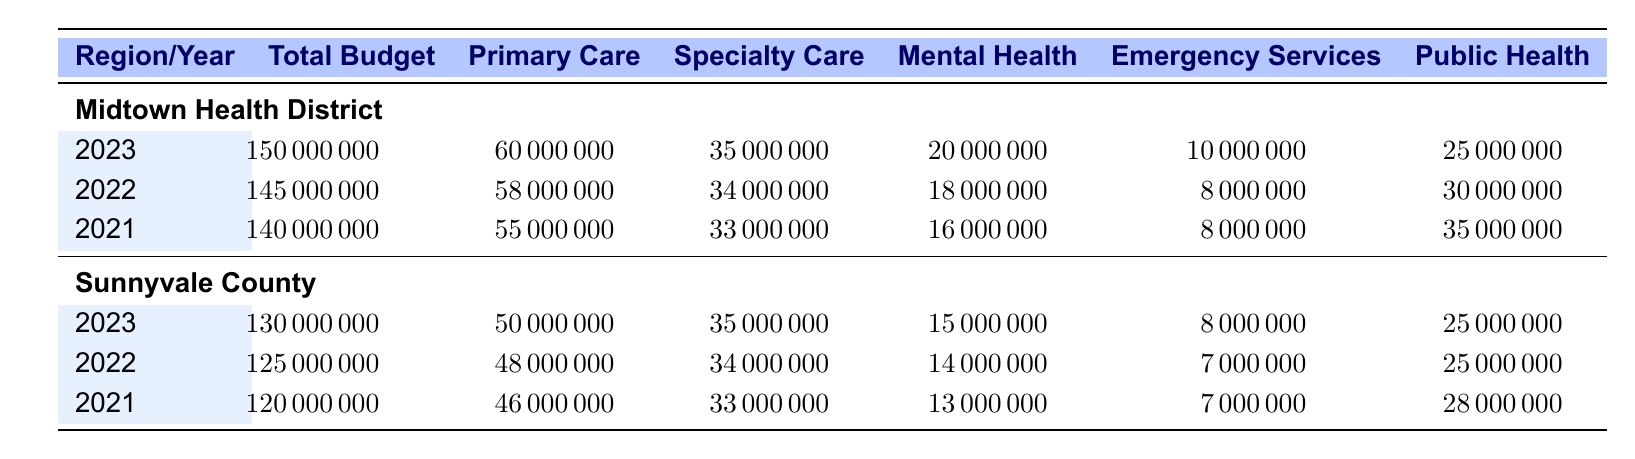What was the total healthcare budget for Midtown Health District in 2023? The table explicitly shows the total budget for Midtown Health District in 2023 as 150,000,000.
Answer: 150000000 How much was allocated to Mental Health in Sunnyvale County for the year 2022? Looking at the Sunnyvale County row for the year 2022, the allocation for Mental Health is clearly listed as 14,000,000.
Answer: 14000000 What is the difference in total budget between Midtown Health District in 2023 and 2022? To find the difference, I subtract the 2022 total budget (145,000,000) from the 2023 total budget (150,000,000), resulting in a difference of 5,000,000.
Answer: 5000000 Did Midtown Health District have a higher budget for Emergency Services in 2023 than Sunnyvale County in the same year? The Emergency Services budget for Midtown Health District in 2023 is 10,000,000 and for Sunnyvale County in 2023, it is 8,000,000. Since 10,000,000 is greater than 8,000,000, the answer is yes.
Answer: Yes What is the average allocation for Specialty Care across both regions for the year 2021? First, I find the Specialty Care allocation for both regions in 2021: Midtown Health District is 33,000,000 and Sunnyvale County is 33,000,000. Adding these gives 66,000,000. There are 2 data points, so the average is 66,000,000 divided by 2 = 33,000,000.
Answer: 33000000 In which year did Midtown Health District allocate the most to Public Health Initiatives? Looking at the Public Health Initiatives for Midtown Health District, in 2021 it was 35,000,000, in 2022 it was 30,000,000, and in 2023 it was 25,000,000. The highest amount is in 2021.
Answer: 2021 Was there an increase in Primary Care funding from 2021 to 2022 in Sunnyvale County? The funding for Primary Care in Sunnyvale County was 46,000,000 in 2021 and increased to 48,000,000 in 2022, showing indeed that there was an increase.
Answer: Yes What was the total healthcare budget for 2023 across both regions? To calculate the total for 2023, I add the budgets for Midtown Health District (150,000,000) and Sunnyvale County (130,000,000), resulting in 280,000,000.
Answer: 280000000 